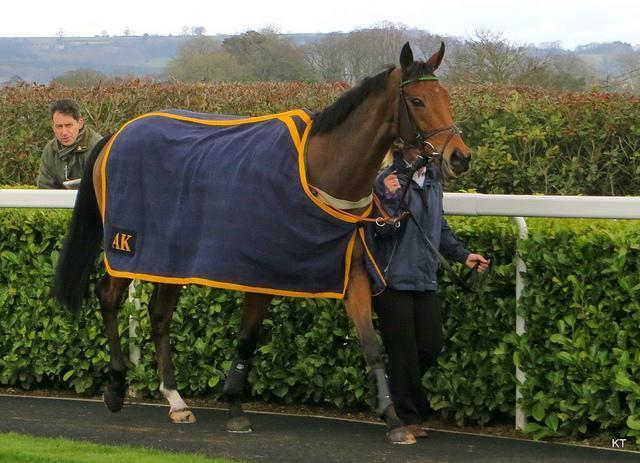How many people are there?
Give a very brief answer. 2. How many zebras are eating grass in the image? there are zebras not eating grass too?
Give a very brief answer. 0. 